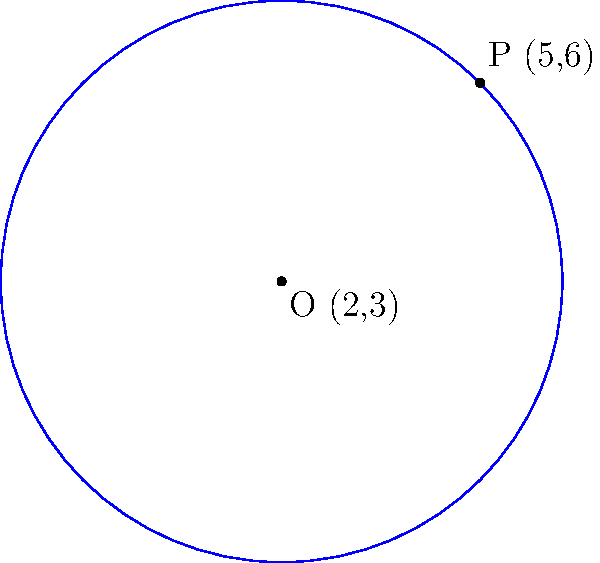In the given coordinate plane, a circle is shown with center O at (2,3) and a point P (5,6) on its circumference. Determine the equation of this circle. To find the equation of the circle, we'll follow these steps:

1) The general equation of a circle is $$(x-h)^2 + (y-k)^2 = r^2$$
   where (h,k) is the center and r is the radius.

2) We're given the center O (2,3), so h = 2 and k = 3.

3) To find r, we need to calculate the distance between O and P:
   $$r^2 = (x_P - x_O)^2 + (y_P - y_O)^2$$
   $$r^2 = (5 - 2)^2 + (6 - 3)^2 = 3^2 + 3^2 = 18$$

4) Now we can substitute these values into the general equation:
   $$(x-2)^2 + (y-3)^2 = 18$$

5) This is the equation of the circle in its standard form.

6) If we expand this, we get:
   $$x^2 - 4x + 4 + y^2 - 6y + 9 = 18$$
   $$x^2 + y^2 - 4x - 6y - 5 = 0$$

This is the general form of the circle equation.
Answer: $(x-2)^2 + (y-3)^2 = 18$ or $x^2 + y^2 - 4x - 6y - 5 = 0$ 